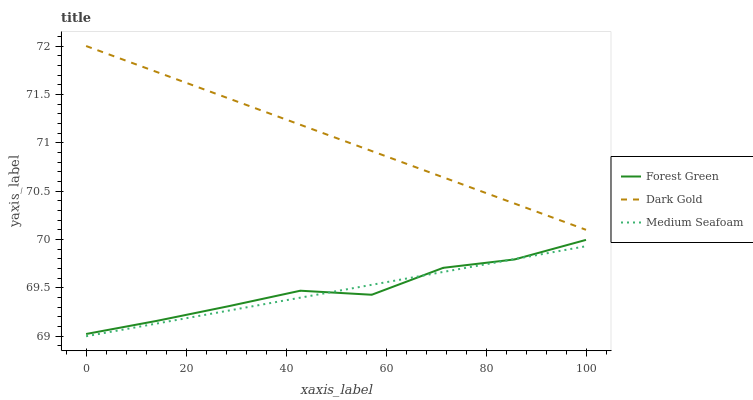Does Medium Seafoam have the minimum area under the curve?
Answer yes or no. Yes. Does Dark Gold have the maximum area under the curve?
Answer yes or no. Yes. Does Dark Gold have the minimum area under the curve?
Answer yes or no. No. Does Medium Seafoam have the maximum area under the curve?
Answer yes or no. No. Is Medium Seafoam the smoothest?
Answer yes or no. Yes. Is Forest Green the roughest?
Answer yes or no. Yes. Is Dark Gold the smoothest?
Answer yes or no. No. Is Dark Gold the roughest?
Answer yes or no. No. Does Medium Seafoam have the lowest value?
Answer yes or no. Yes. Does Dark Gold have the lowest value?
Answer yes or no. No. Does Dark Gold have the highest value?
Answer yes or no. Yes. Does Medium Seafoam have the highest value?
Answer yes or no. No. Is Medium Seafoam less than Dark Gold?
Answer yes or no. Yes. Is Dark Gold greater than Forest Green?
Answer yes or no. Yes. Does Medium Seafoam intersect Forest Green?
Answer yes or no. Yes. Is Medium Seafoam less than Forest Green?
Answer yes or no. No. Is Medium Seafoam greater than Forest Green?
Answer yes or no. No. Does Medium Seafoam intersect Dark Gold?
Answer yes or no. No. 